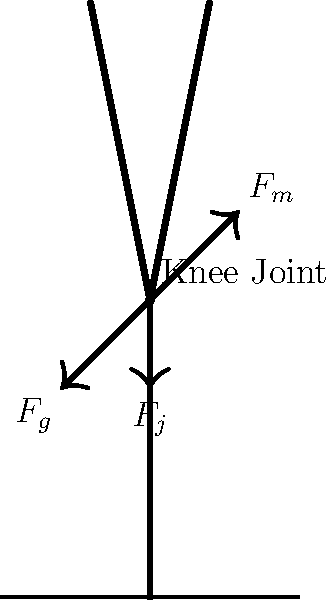Based on the diagram showing force distribution on a knee joint during walking, which force is most likely to contribute to the development of osteoarthritis in elderly patients if consistently elevated over time? To answer this question, let's analyze the forces acting on the knee joint during walking:

1. $F_m$: This represents the muscle force, primarily from the quadriceps, which helps to extend the knee and control movement.

2. $F_g$: This is the ground reaction force, which is the force exerted by the ground on the foot and transmitted up through the leg.

3. $F_j$: This represents the joint reaction force, which is the internal force acting within the knee joint itself.

The joint reaction force ($F_j$) is of particular interest in the context of osteoarthritis because:

1. It represents the total compressive force acting on the articular cartilage and subchondral bone within the knee joint.

2. Excessive and repetitive loading of this force can lead to cartilage degradation over time.

3. In elderly patients, the ability of cartilage to withstand and recover from mechanical stress is reduced.

4. Consistently elevated joint reaction forces can accelerate the wear and tear process, leading to the development or progression of osteoarthritis.

5. While muscle forces ($F_m$) and ground reaction forces ($F_g$) contribute to the overall joint loading, it's the internal joint reaction force that directly affects the articular surfaces.

Therefore, from a biomechanical perspective, consistently elevated joint reaction force ($F_j$) is most likely to contribute to the development of osteoarthritis in elderly patients over time.
Answer: Joint reaction force ($F_j$) 